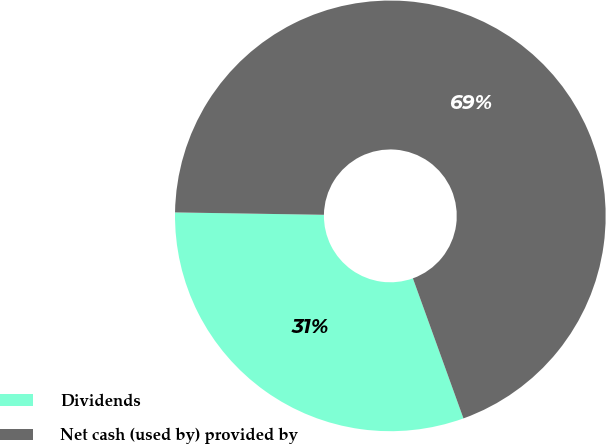Convert chart to OTSL. <chart><loc_0><loc_0><loc_500><loc_500><pie_chart><fcel>Dividends<fcel>Net cash (used by) provided by<nl><fcel>30.77%<fcel>69.23%<nl></chart> 